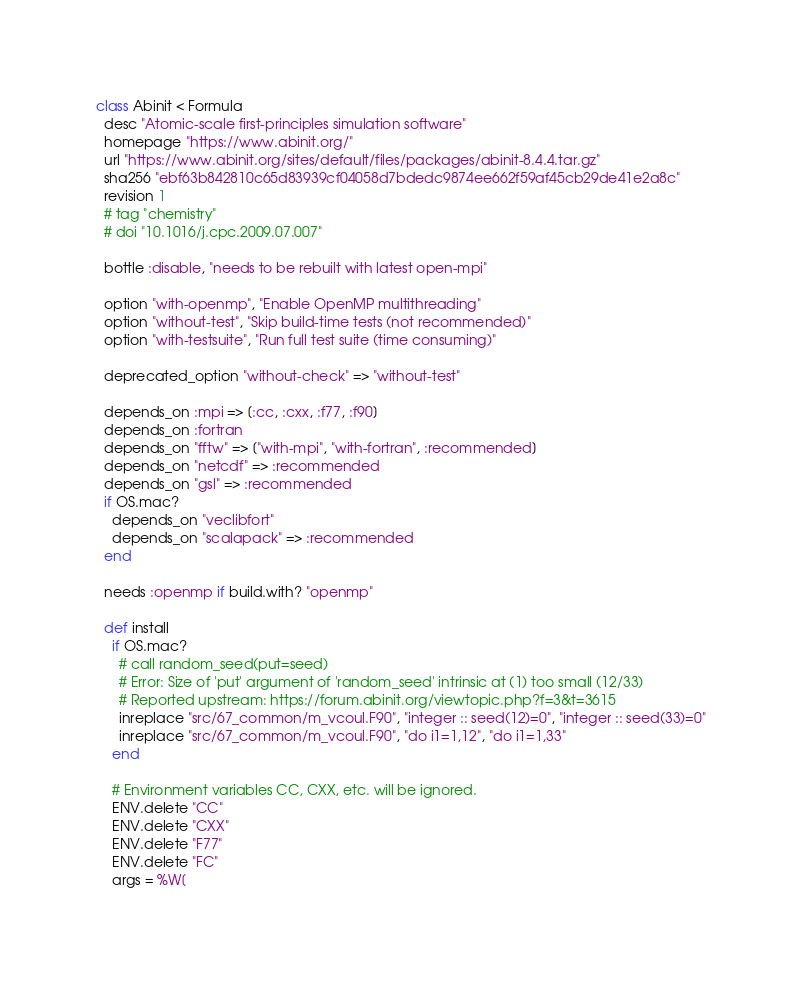Convert code to text. <code><loc_0><loc_0><loc_500><loc_500><_Ruby_>class Abinit < Formula
  desc "Atomic-scale first-principles simulation software"
  homepage "https://www.abinit.org/"
  url "https://www.abinit.org/sites/default/files/packages/abinit-8.4.4.tar.gz"
  sha256 "ebf63b842810c65d83939cf04058d7bdedc9874ee662f59af45cb29de41e2a8c"
  revision 1
  # tag "chemistry"
  # doi "10.1016/j.cpc.2009.07.007"

  bottle :disable, "needs to be rebuilt with latest open-mpi"

  option "with-openmp", "Enable OpenMP multithreading"
  option "without-test", "Skip build-time tests (not recommended)"
  option "with-testsuite", "Run full test suite (time consuming)"

  deprecated_option "without-check" => "without-test"

  depends_on :mpi => [:cc, :cxx, :f77, :f90]
  depends_on :fortran
  depends_on "fftw" => ["with-mpi", "with-fortran", :recommended]
  depends_on "netcdf" => :recommended
  depends_on "gsl" => :recommended
  if OS.mac?
    depends_on "veclibfort"
    depends_on "scalapack" => :recommended
  end

  needs :openmp if build.with? "openmp"

  def install
    if OS.mac?
      # call random_seed(put=seed)
      # Error: Size of 'put' argument of 'random_seed' intrinsic at (1) too small (12/33)
      # Reported upstream: https://forum.abinit.org/viewtopic.php?f=3&t=3615
      inreplace "src/67_common/m_vcoul.F90", "integer :: seed(12)=0", "integer :: seed(33)=0"
      inreplace "src/67_common/m_vcoul.F90", "do i1=1,12", "do i1=1,33"
    end

    # Environment variables CC, CXX, etc. will be ignored.
    ENV.delete "CC"
    ENV.delete "CXX"
    ENV.delete "F77"
    ENV.delete "FC"
    args = %W[</code> 